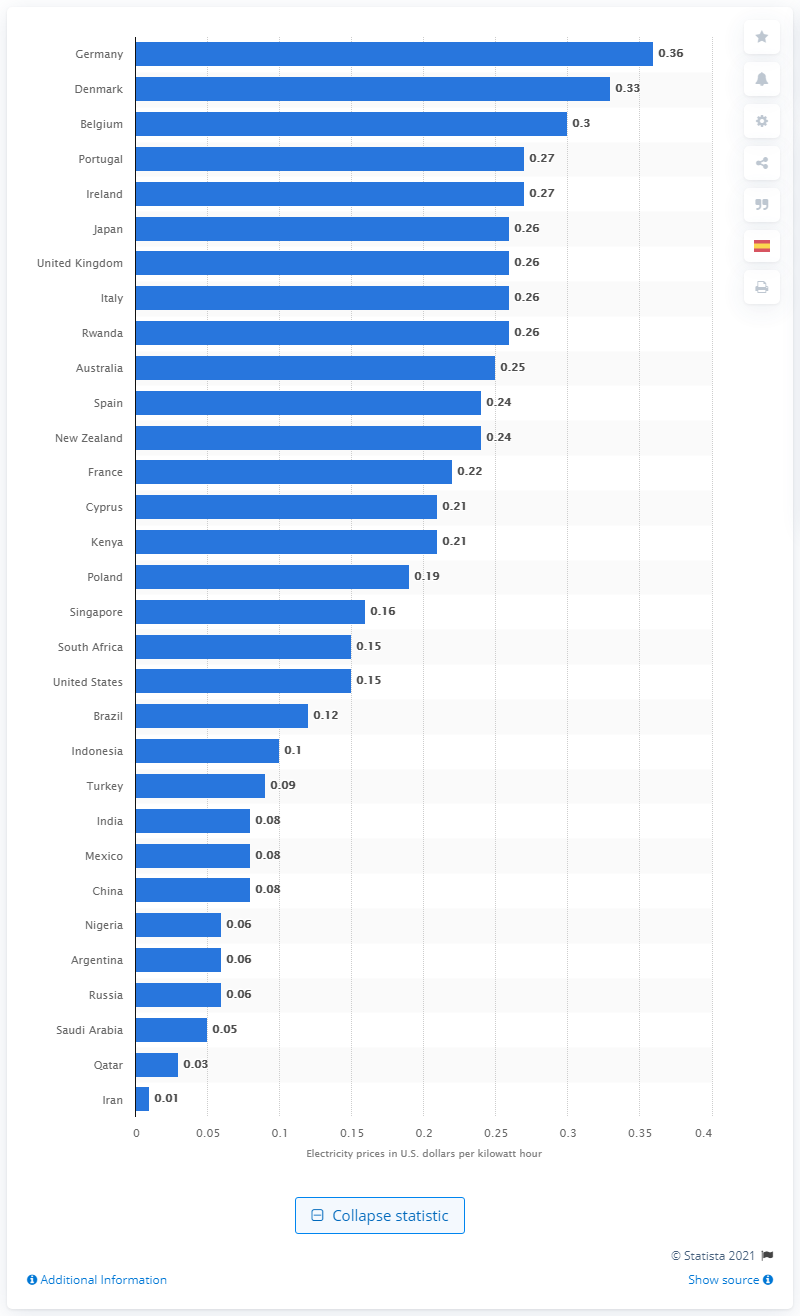Specify some key components in this picture. In September 2020, the value added tax per kilowatt hour in Germany was 0.36. Germany has the highest electricity prices worldwide. In Poland, our neighbor pays half the amount per kilowatt hour as we do, and tax is included in their cost. 